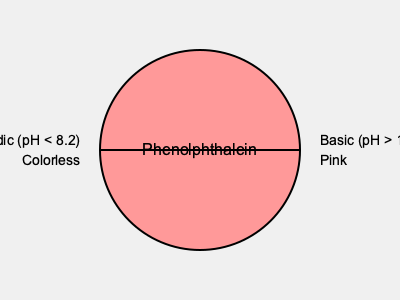In your sculpture utilizing color-changing reactions, you decide to incorporate phenolphthalein as a pH indicator. Explain how the molecular structure of phenolphthalein changes when transitioning from acidic to basic conditions, and how this structural change results in the observed color shift. Additionally, propose a method to reversibly control this color change in your artwork. 1. Molecular structure in acidic conditions:
   - In acidic conditions (pH < 8.2), phenolphthalein exists in its lactone form.
   - The molecule is non-planar and has a spiro carbon center.
   - This structure does not allow for extensive conjugation, resulting in no visible color (colorless).

2. Molecular structure in basic conditions:
   - In basic conditions (pH > 10.0), the lactone ring opens.
   - The molecule becomes planar and loses its spiro carbon center.
   - This results in extended conjugation throughout the molecule.

3. Color change mechanism:
   - The extended conjugation in the basic form allows for absorption of light in the visible spectrum.
   - Specifically, it absorbs green light (around 550 nm wavelength).
   - This absorption results in the complementary color, pink, being observed.

4. Structural changes affecting color:
   - The change from non-planar to planar structure is key.
   - Extended conjugation in the planar form allows for electron delocalization.
   - This delocalization reduces the energy gap between HOMO and LUMO, shifting absorption to the visible range.

5. Reversible control in artwork:
   - Use a system that can alternate between acidic and basic conditions.
   - Proposal: Create a sealed chamber with phenolphthalein solution.
   - Install two gas inlets: one for CO₂ (to create carbonic acid, lowering pH) and one for NH₃ (to create a basic environment).
   - Alternately introduce these gases to reversibly change the pH and, consequently, the color.

6. Artistic application:
   - This system could be incorporated into a kinetic sculpture.
   - The color change can be timed or triggered by viewer interaction.
   - The gradual color shift can create a dynamic, evolving visual experience.
Answer: Phenolphthalein changes from a non-planar lactone (colorless) in acidic conditions to a planar, conjugated structure (pink) in basic conditions. Control color change by alternating CO₂ and NH₃ gas exposure. 